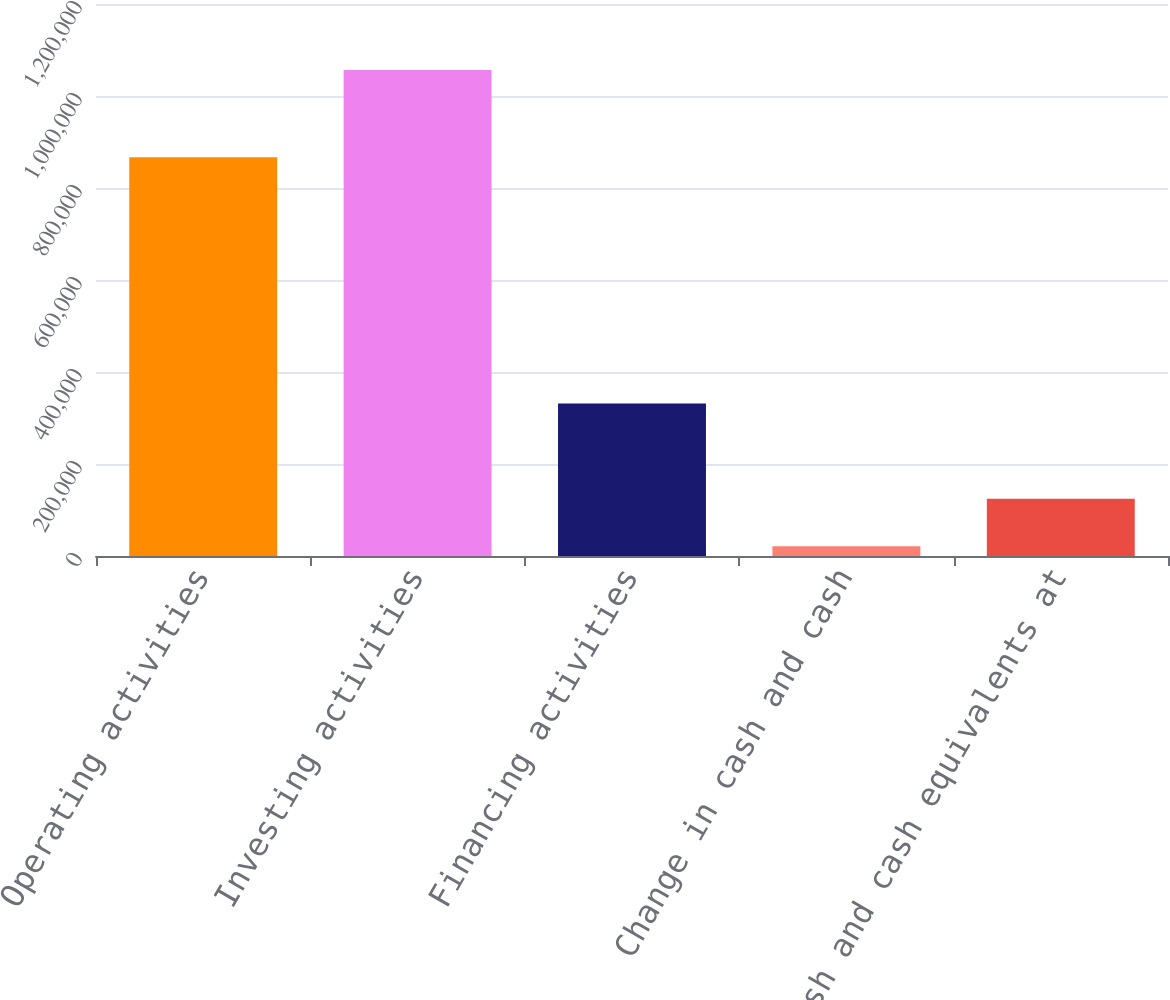Convert chart. <chart><loc_0><loc_0><loc_500><loc_500><bar_chart><fcel>Operating activities<fcel>Investing activities<fcel>Financing activities<fcel>Change in cash and cash<fcel>Cash and cash equivalents at<nl><fcel>867090<fcel>1.05631e+06<fcel>331679<fcel>21125<fcel>124643<nl></chart> 